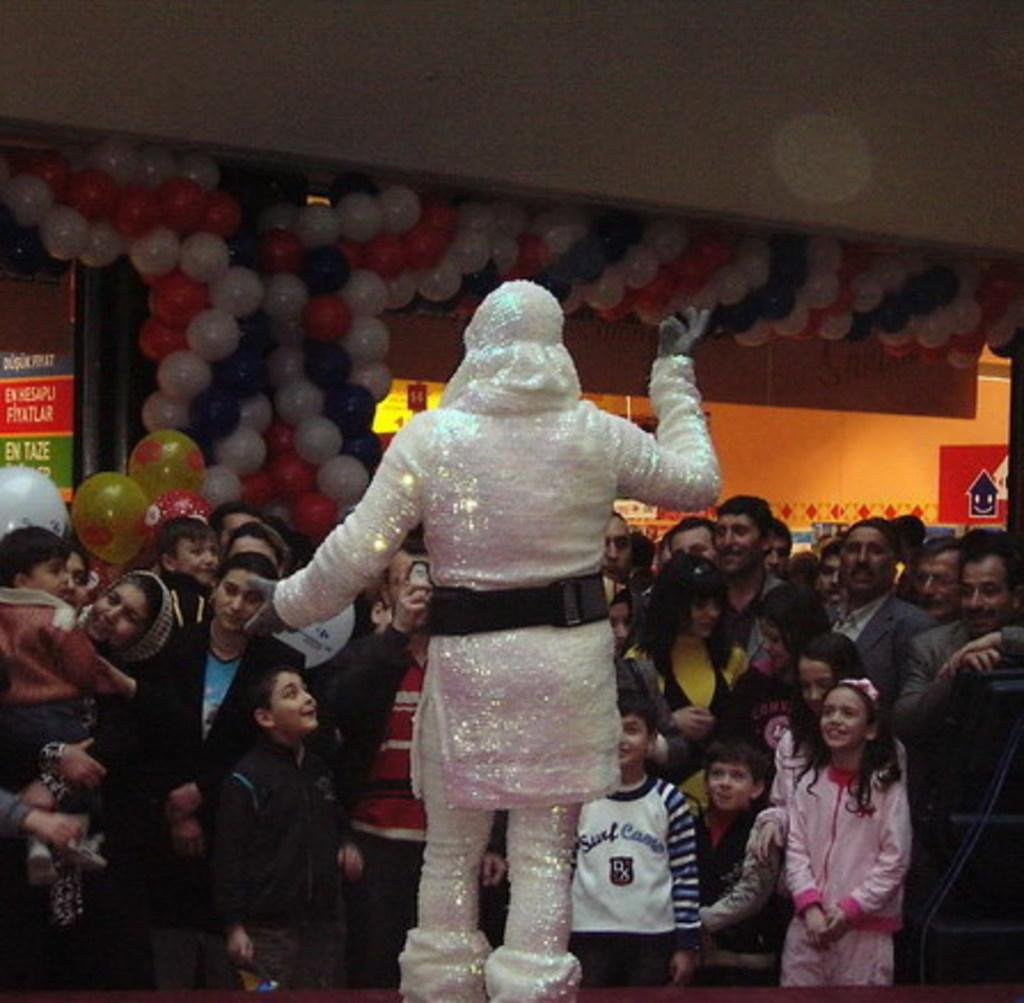What is the person in the image wearing? The person in the image is wearing a fancy dress. What is happening around the person in the fancy dress? There are other people standing in front of the person in the fancy dress. What decorations can be seen on the wall in the image? There are balloons on the wall in the image. What other elements are present in the image? There are unspecified "other things" in the image. What type of punishment is being administered in the image? There is no indication of punishment in the image; it features a person in a fancy dress with other people and balloons. Where is the lunchroom located in the image? There is no mention of a lunchroom in the image; it only shows a person in a fancy dress, other people, balloons, and unspecified "other things." 